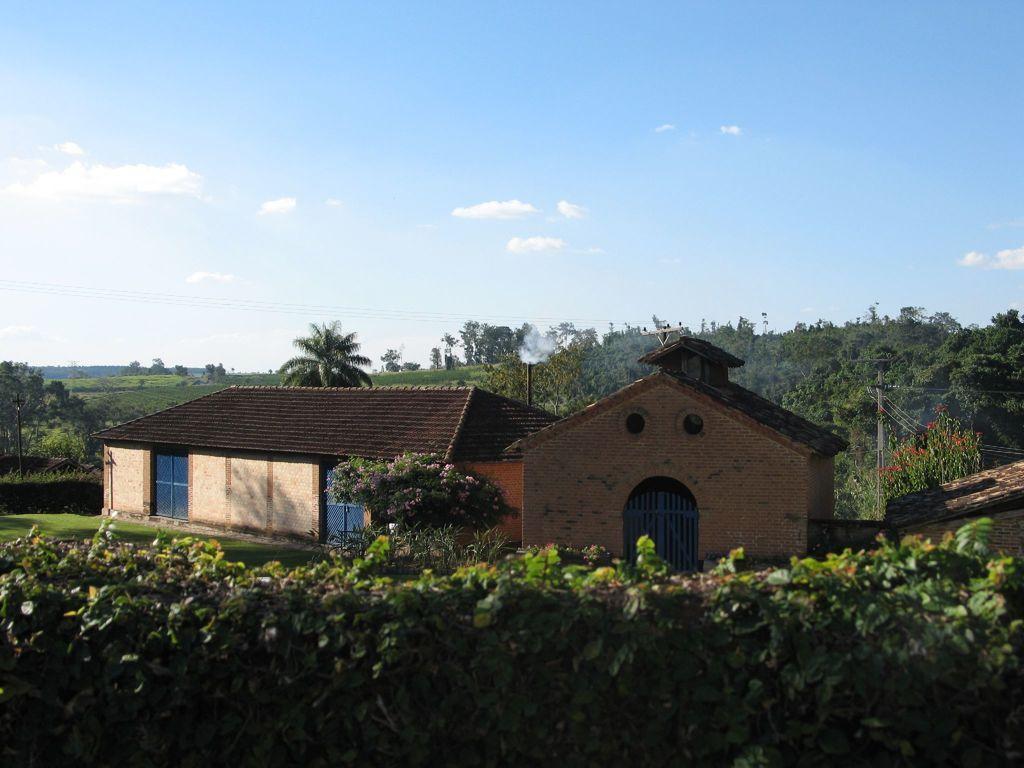How would you summarize this image in a sentence or two? In this image I see few houses and I see the plants over here and I see number of trees and I see a pole over here and I see the wires and I see the smoke over here. In the background I see the clear sky. 